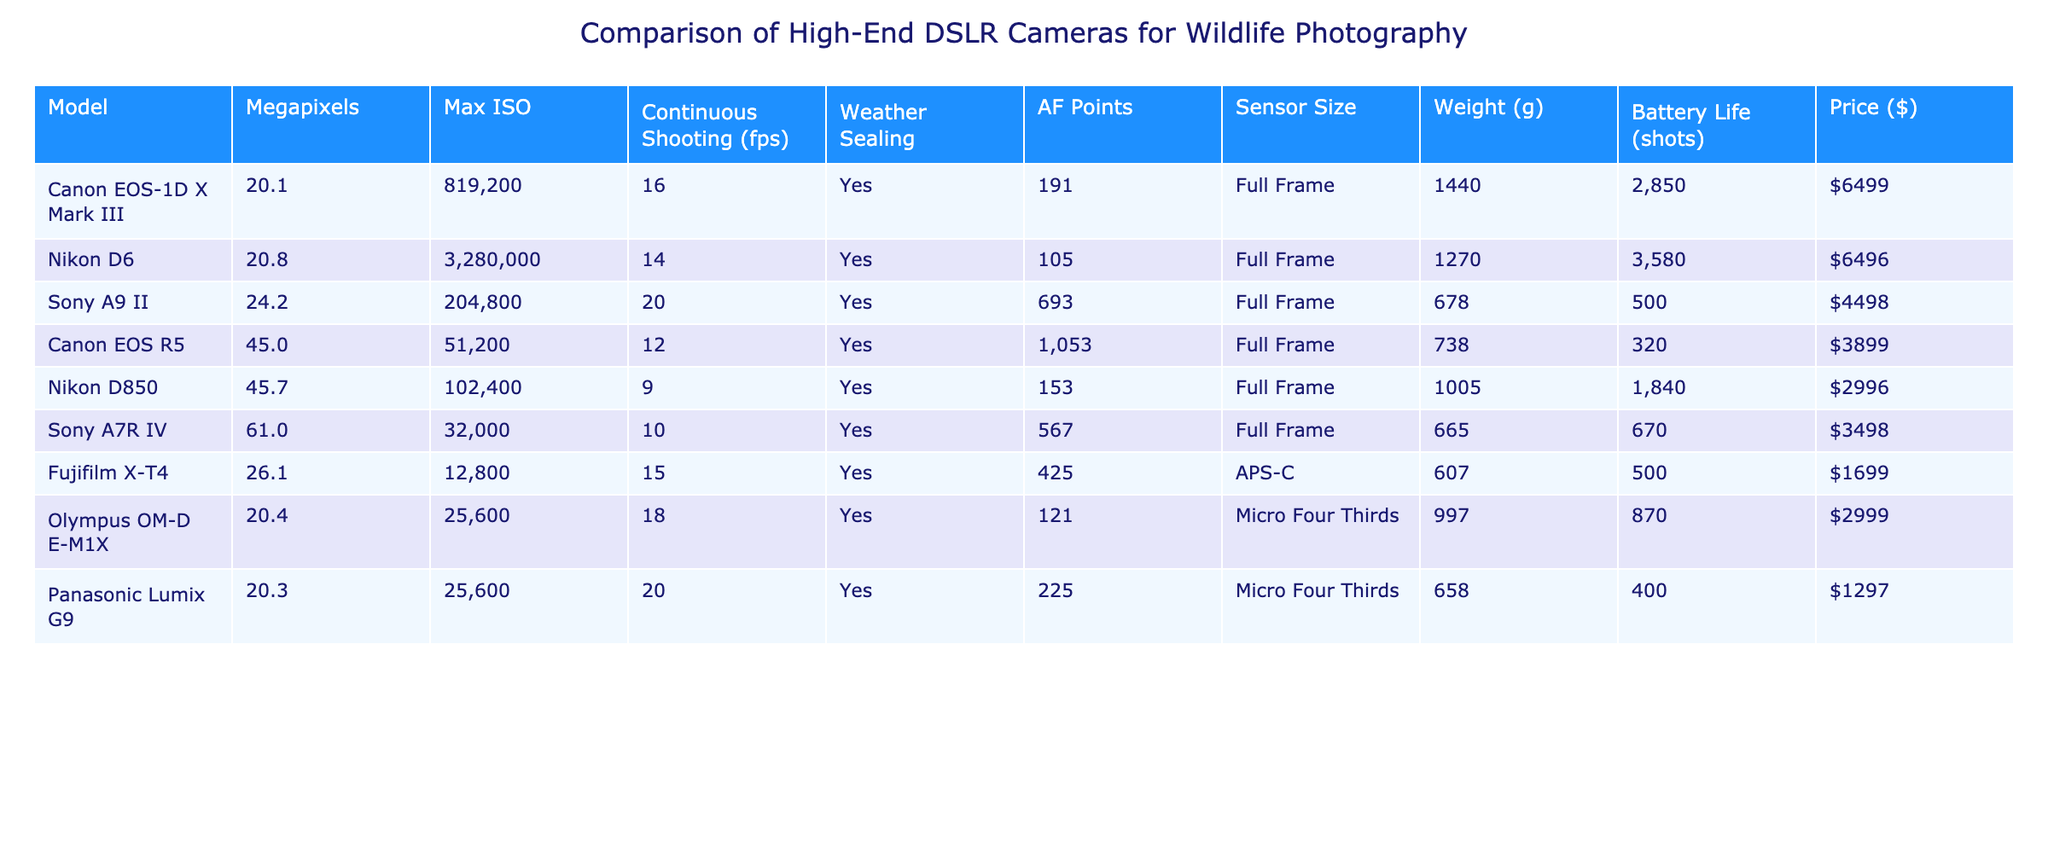What is the maximum ISO of the Nikon D6? The table shows that the maximum ISO for the Nikon D6 is listed as 3,280,000.
Answer: 3,280,000 Which camera has the highest resolution in megapixels? The Canon EOS R5 has 45 megapixels, while the Nikon D850 has 45.7 megapixels, making it the highest resolution camera at 45.7 megapixels.
Answer: 45.7 How much does the Sony A9 II weigh? According to the table, the Sony A9 II has a weight of 678 grams.
Answer: 678 grams Which camera has the longest battery life? The Nikon D6 has a battery life of 3,580 shots, which is the longest among the listed cameras.
Answer: 3,580 shots Is the Canon EOS R5 weather-sealed? The table indicates that the Canon EOS R5 has weather sealing marked as "Yes."
Answer: Yes What is the weight difference between the Canon EOS-1D X Mark III and the Fujifilm X-T4? The Canon EOS-1D X Mark III weighs 1,440 grams, while the Fujifilm X-T4 weighs 607 grams. The weight difference is 1,440 - 607 = 833 grams.
Answer: 833 grams How many continuous frames per second does the Olympus OM-D E-M1X shoot? The table states that the Olympus OM-D E-M1X offers continuous shooting at 18 frames per second.
Answer: 18 fps Which two cameras have a maximum ISO above 100,000? From the table, the Nikon D6 has a maximum ISO of 3,280,000 and the Canon EOS-1D X Mark III has an ISO of 819,200. Both exceed 100,000.
Answer: Nikon D6 and Canon EOS-1D X Mark III Calculate the average price of all the cameras listed. The prices of the cameras are 6,499, 6,496, 4,498, 3,899, 2,996, 3,498, 1,699, 2,999, and 1,297. Summing them gives 29,451, and dividing by the number of cameras, which is 8, the average is 29,451 / 8 = 3,681.375, which can be rounded to 3,681.
Answer: 3,681 Which camera offers the best combination of high AF points and low weight? The Sony A9 II has 693 AF points and weighs 678 grams, making it a strong performer in both metrics compared to others on the list.
Answer: Sony A9 II 